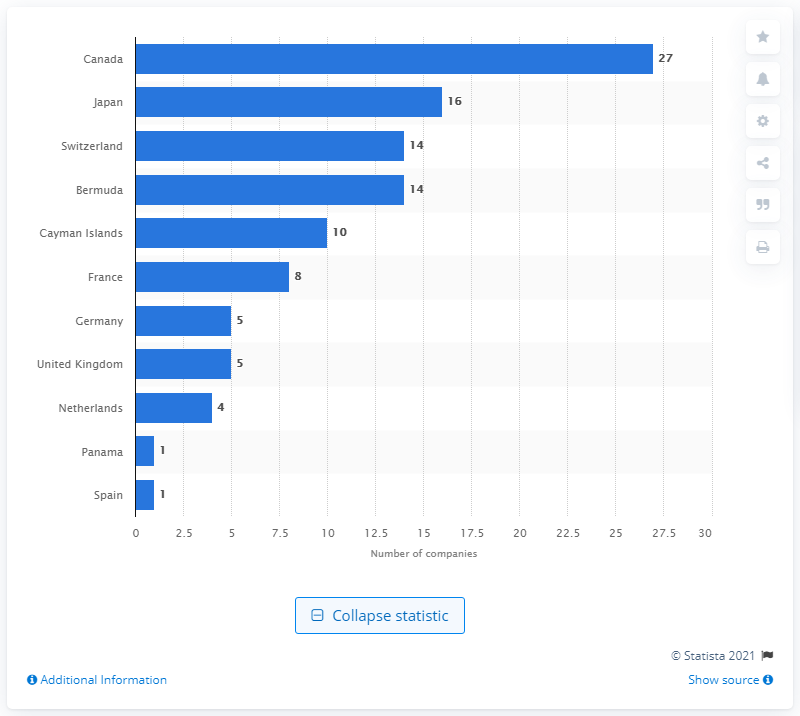Highlight a few significant elements in this photo. In 2018, there were 27 Canadian life insurance companies operating in the United States. 